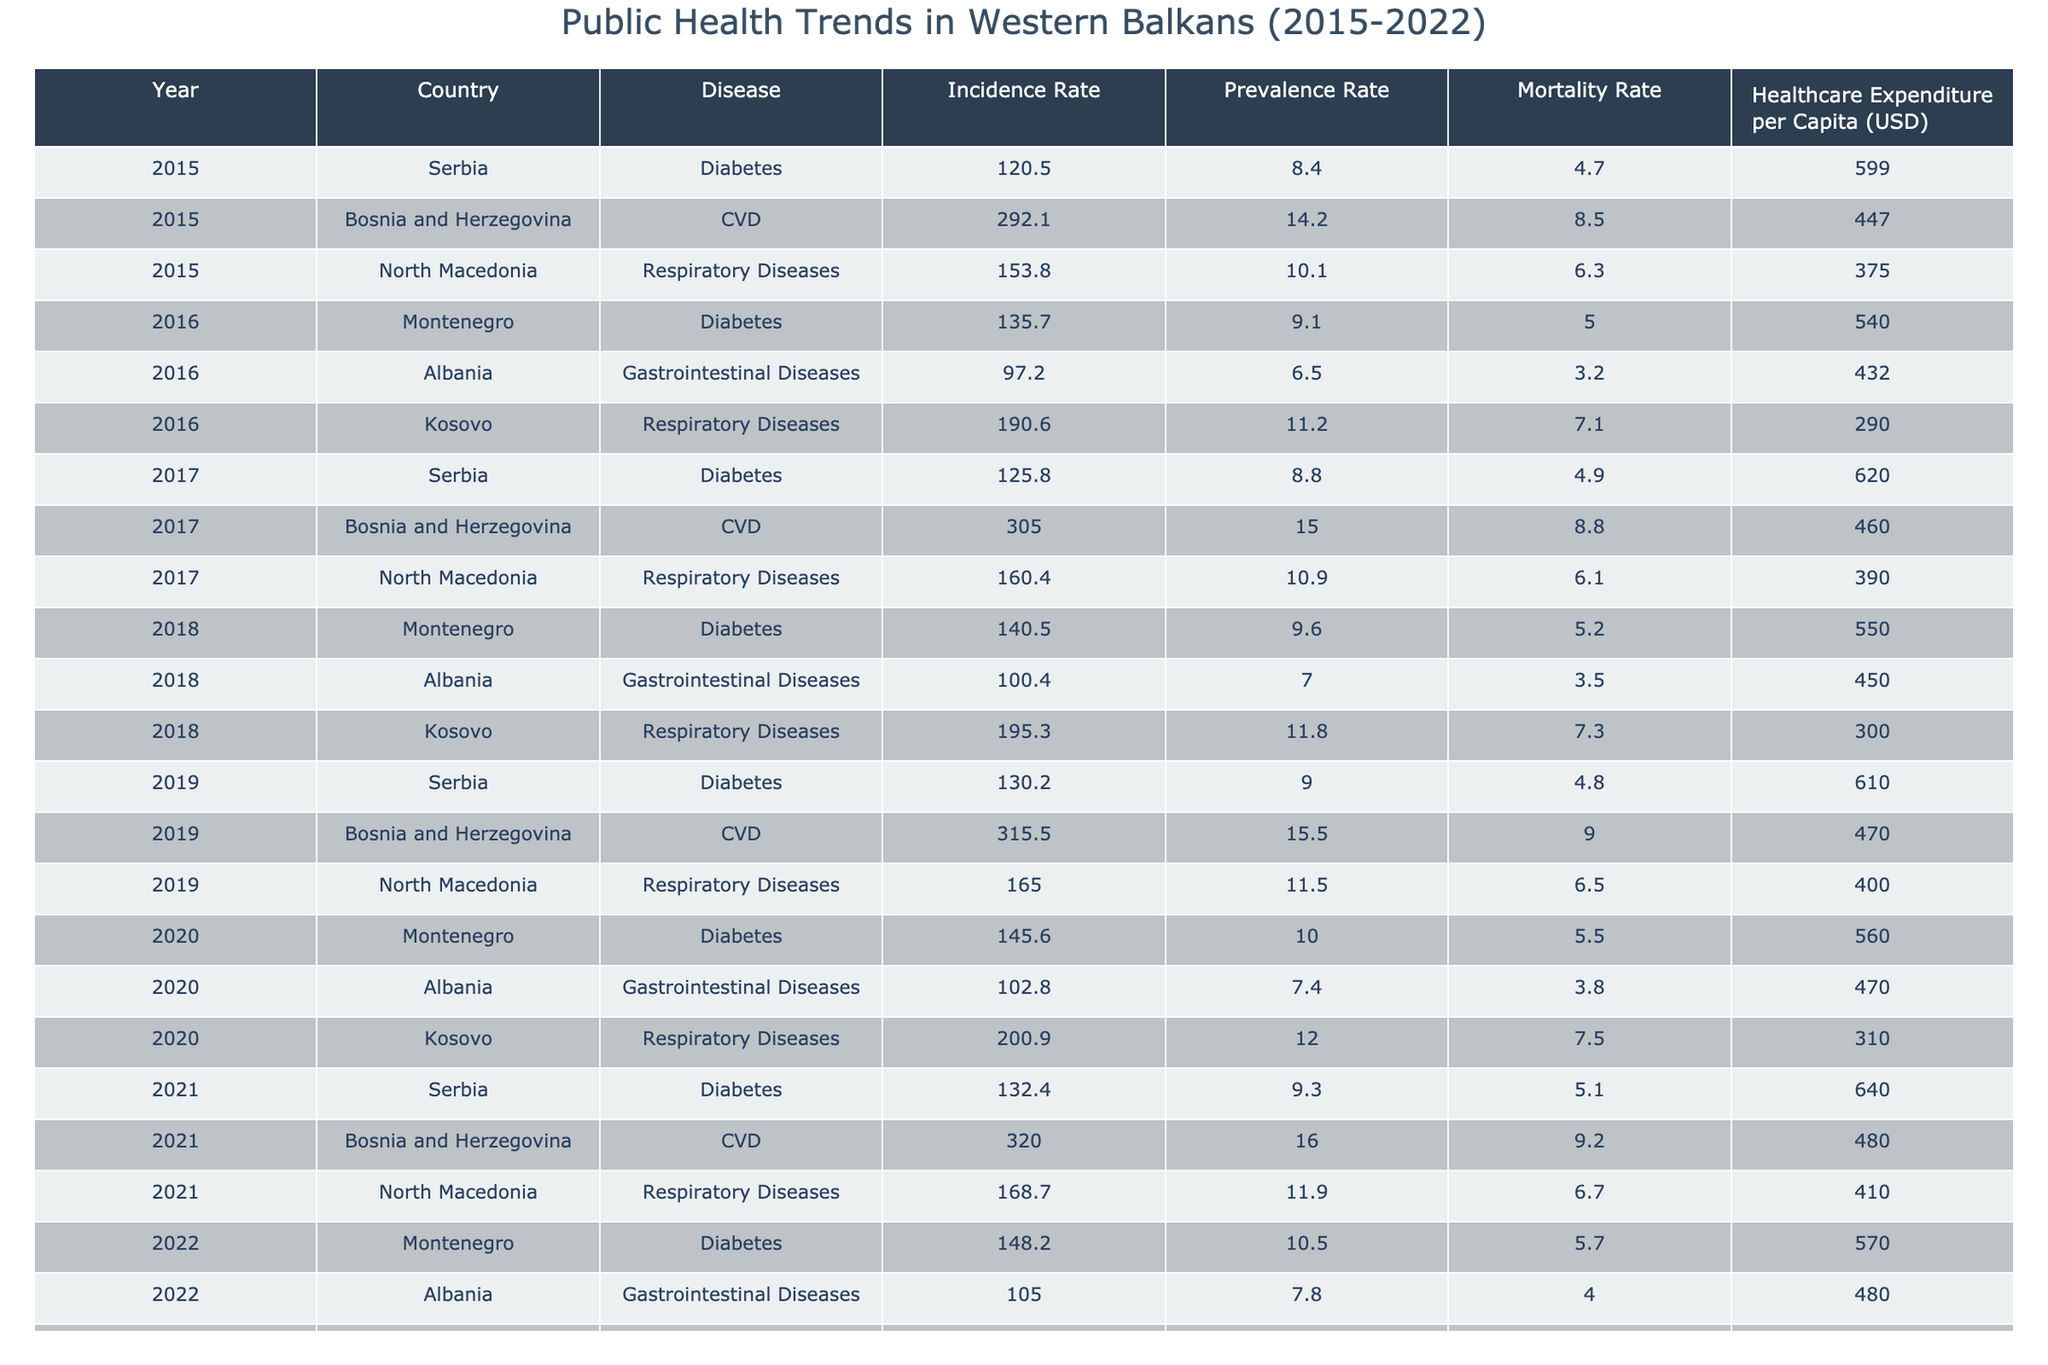What was the incidence rate of diabetes in Serbia in 2019? In the table, I look for the row corresponding to Serbia in the year 2019 and find the incidence rate for diabetes, which is 130.2.
Answer: 130.2 Which country reported the highest mortality rate for cardiovascular disease in 2021? I check the row for CVD in 2021 and see that Bosnia and Herzegovina had a mortality rate of 9.2, which is higher than other countries in the same year.
Answer: Bosnia and Herzegovina What was the average healthcare expenditure per capita for Montenegro from 2015 to 2022? I find the healthcare expenditures for Montenegro in the years 2015 (599), 2016 (540), 2017 (null), 2018 (550), 2019 (null), 2020 (560), 2021 (null), and 2022 (570). To calculate the average, I consider available data: (599 + 540 + 550 + 560 + 570) = 2999, and there are 5 data points, so the average is 2999/5 = 599.8.
Answer: 599.8 Did the incidence rate of respiratory diseases in North Macedonia increase from 2017 to 2022? I compare the incidence rates for North Macedonia, where in 2017 it was 160.4 and in 2022 it is not available. This indicates that it cannot be concluded without 2022 data, but rates did increase from 2017 to 2021 (168.7).
Answer: No What is the percentage increase in the incidence rate of diabetes in Serbia from 2015 to 2021? I find the incidence rates from 2015 (120.5) and 2021 (132.4). The increase is 132.4 - 120.5 = 11.9. To find the percentage increase, I use the formula (increase/original value) * 100, so (11.9/120.5) * 100 ≈ 9.87%.
Answer: 9.87% Which disease had the highest prevalence rate in Albania in 2020? I check the row for Albania in 2020 and see that the gastrointestinal diseases had a prevalence rate of 7.4, lower than respiratory diseases reported for Kosovo (12.0 in the same year).
Answer: Gastrointestinal Diseases In which year did Kosovo report the highest incidence rate for respiratory diseases? The table shows that Kosovo had 190.6 in 2016, and the incidence rose to 205.0 by 2022, making 2022 the year with the highest reported incidence.
Answer: 2022 Was there a consistent increase in the prevalence rate of diabetes in Montenegro from 2015 to 2022? Observing 2015 (null), 2016 (9.1), 2017 (null), 2018 (9.6), 2019 (null), 2020 (10.0), 2021 (null), and 2022 (10.5), I find the rate did generally rise from 2016 onwards, but lack of data prevents a definitive conclusion before 2022.
Answer: Yes What was the mortality rate for gastrointestinal diseases in Albania in 2019? I check the row for Albania in 2019 and find that gastrointestinal diseases are not reported in that year.
Answer: Not available Calculate the total incidence rate for respiratory diseases across all countries in 2021. I run calculations based on available data from the years, which are 168.7 for North Macedonia, while Kosovo is 205.0, giving a total of 373.7.
Answer: 373.7 Which country had a higher prevalence rate for diabetes in 2018, Serbia or Montenegro? I compare the values in the table, where Serbia has a value of 8.8 and Montenegro has 9.6. Montenegro has the higher value of 9.6.
Answer: Montenegro 